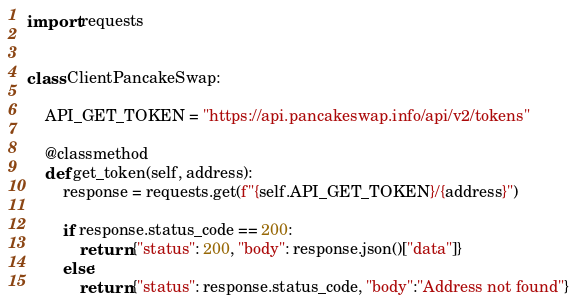<code> <loc_0><loc_0><loc_500><loc_500><_Python_>import requests


class ClientPancakeSwap:

    API_GET_TOKEN = "https://api.pancakeswap.info/api/v2/tokens"

    @classmethod
    def get_token(self, address):
        response = requests.get(f"{self.API_GET_TOKEN}/{address}")
        
        if response.status_code == 200:
            return {"status": 200, "body": response.json()["data"]} 
        else:
            return {"status": response.status_code, "body":"Address not found"}
</code> 